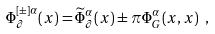Convert formula to latex. <formula><loc_0><loc_0><loc_500><loc_500>\Phi ^ { [ \pm ] \alpha } _ { \partial } ( x ) = \widetilde { \Phi } _ { \partial } ^ { \alpha } ( x ) \pm \pi \Phi _ { G } ^ { \alpha } ( x , x ) \ ,</formula> 